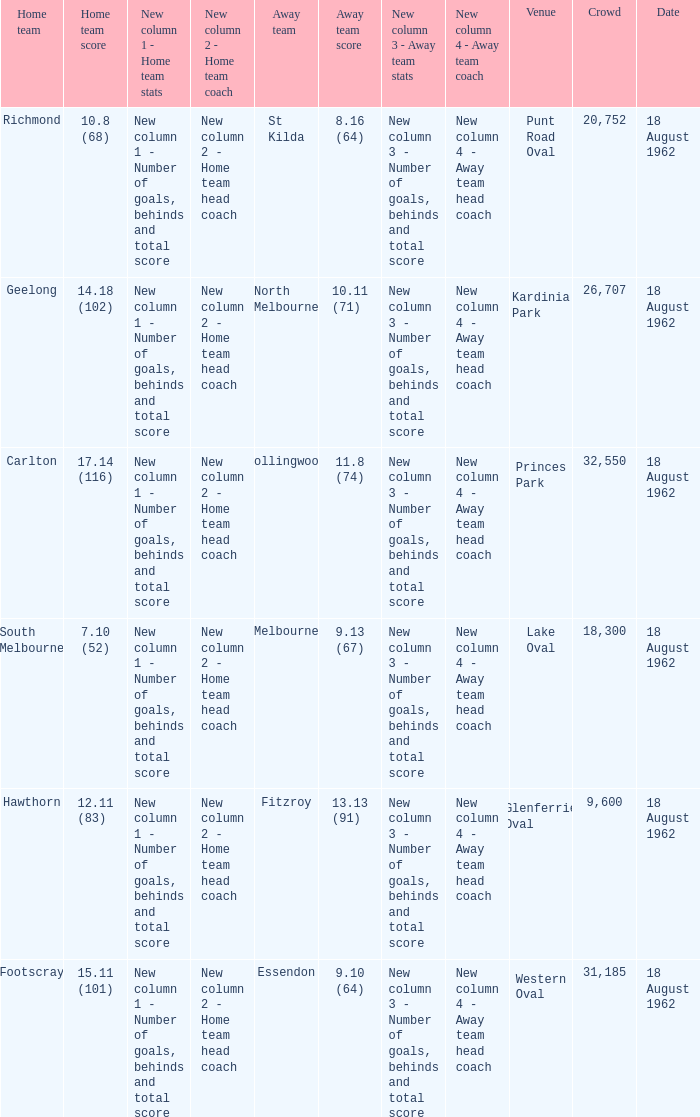Who was the rival team when the home team registered 1 St Kilda. 